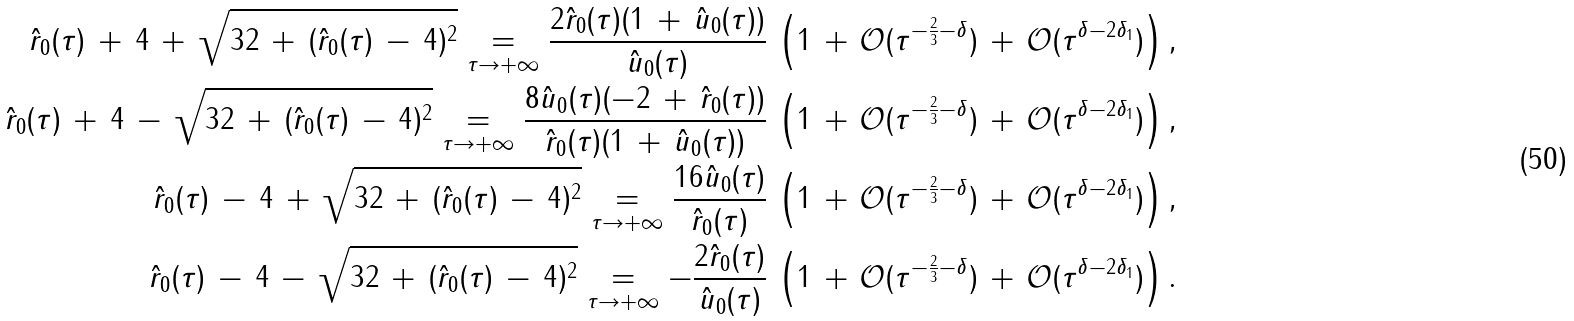Convert formula to latex. <formula><loc_0><loc_0><loc_500><loc_500>\hat { r } _ { 0 } ( \tau ) \, + \, 4 \, + \, \sqrt { 3 2 \, + \, ( \hat { r } _ { 0 } ( \tau ) \, - \, 4 ) ^ { 2 } } \underset { \tau \to + \infty } { = } \frac { 2 \hat { r } _ { 0 } ( \tau ) ( 1 \, + \, \hat { u } _ { 0 } ( \tau ) ) } { \hat { u } _ { 0 } ( \tau ) } \, \left ( 1 \, + \, \mathcal { O } ( \tau ^ { - \frac { 2 } { 3 } - \delta } ) \, + \, \mathcal { O } ( \tau ^ { \delta - 2 \delta _ { 1 } } ) \right ) , \\ \hat { r } _ { 0 } ( \tau ) \, + \, 4 \, - \, \sqrt { 3 2 \, + \, ( \hat { r } _ { 0 } ( \tau ) \, - \, 4 ) ^ { 2 } } \underset { \tau \to + \infty } { = } \frac { 8 \hat { u } _ { 0 } ( \tau ) ( - 2 \, + \, \hat { r } _ { 0 } ( \tau ) ) } { \hat { r } _ { 0 } ( \tau ) ( 1 \, + \, \hat { u } _ { 0 } ( \tau ) ) } \, \left ( 1 \, + \, \mathcal { O } ( \tau ^ { - \frac { 2 } { 3 } - \delta } ) \, + \, \mathcal { O } ( \tau ^ { \delta - 2 \delta _ { 1 } } ) \right ) , \\ \hat { r } _ { 0 } ( \tau ) \, - \, 4 \, + \, \sqrt { 3 2 \, + \, ( \hat { r } _ { 0 } ( \tau ) \, - \, 4 ) ^ { 2 } } \underset { \tau \to + \infty } { = } \frac { 1 6 \hat { u } _ { 0 } ( \tau ) } { \hat { r } _ { 0 } ( \tau ) } \, \left ( 1 \, + \, \mathcal { O } ( \tau ^ { - \frac { 2 } { 3 } - \delta } ) \, + \, \mathcal { O } ( \tau ^ { \delta - 2 \delta _ { 1 } } ) \right ) , \\ \hat { r } _ { 0 } ( \tau ) \, - \, 4 \, - \, \sqrt { 3 2 \, + \, ( \hat { r } _ { 0 } ( \tau ) \, - \, 4 ) ^ { 2 } } \underset { \tau \to + \infty } { = } - \frac { 2 \hat { r } _ { 0 } ( \tau ) } { \hat { u } _ { 0 } ( \tau ) } \, \left ( 1 \, + \, \mathcal { O } ( \tau ^ { - \frac { 2 } { 3 } - \delta } ) \, + \, \mathcal { O } ( \tau ^ { \delta - 2 \delta _ { 1 } } ) \right ) .</formula> 